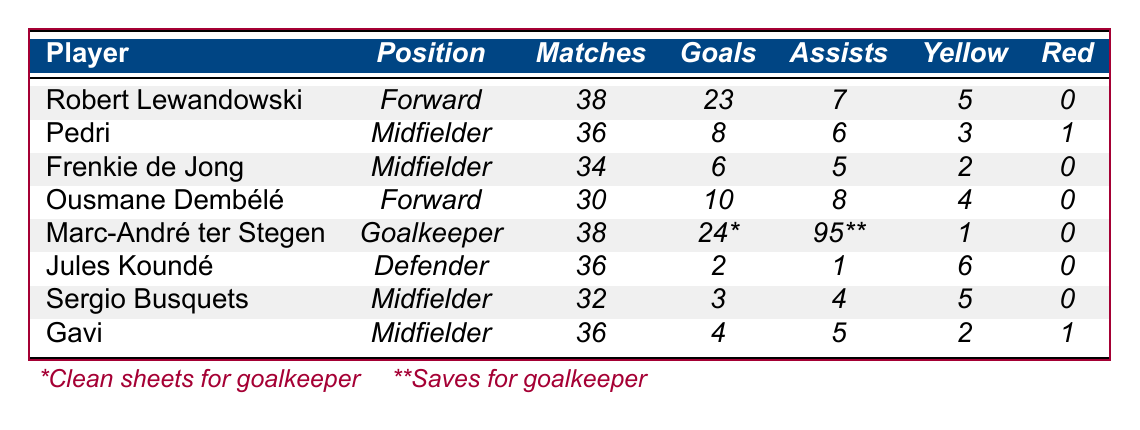What is the total number of goals scored by Robert Lewandowski and Ousmane Dembélé combined? To find the total number of goals scored by Robert Lewandowski, we take his goals (23) and add them to the goals scored by Ousmane Dembélé (10). Therefore, 23 + 10 = 33.
Answer: 33 How many assists did Pedri provide during the season? From the table, Pedri has 6 assists listed. This is directly retrieved from the data.
Answer: 6 Which player received the most yellow cards and how many did they receive? By checking the yellow cards column, we see that Jules Koundé has the highest number with 6 yellow cards compared to other players.
Answer: Jules Koundé, 6 What is the average number of goals scored by midfielders in the season? There are three midfielders (Pedri, Frenkie de Jong, Sergio Busquets, and Gavi) with respective goals of 8, 6, 3, and 4. The sum is 8 + 6 + 3 + 4 = 21. There are 4 midfielders, so the average is 21/4 = 5.25.
Answer: 5.25 Did any player have more red cards than yellow cards? Looking at the table, most players have 0 red cards. Only Pedri and Gavi have red cards, and both have fewer yellow cards than red cards (1 red for each). So the answer is no.
Answer: No How many clean sheets did Marc-André ter Stegen achieve compared to the goals scored by Frenkie de Jong? Marc-André ter Stegen had 24 clean sheets, and Frenkie de Jong scored 6 goals. There is no direct relationship, but simply comparing them finds 24 clean sheets versus 6 goals.
Answer: 24 clean sheets vs. 6 goals What is the total number of matches played by Barcelona FC players listed in the table? By summing up matches played: 38 (Lewandowski) + 36 (Pedri) + 34 (Frenkie de Jong) + 30 (Dembélé) + 38 (ter Stegen) + 36 (Koundé) + 32 (Busquets) + 36 (Gavi) =  38 + 36 + 34 + 30 + 38 + 36 + 32 + 36 =  248.
Answer: 248 Which forward had the highest number of assists? Ousmane Dembélé, with 8 assists, has the highest among forwards. Robert Lewandowski has 7 assists. The answer is determined by comparing their assist statistics.
Answer: Ousmane Dembélé How many total matches did Sergio Busquets and Frenkie de Jong play together? Sergio Busquets played 32 matches and Frenkie de Jong played 34 matches. Adding these two gives 32 + 34 = 66 matches in total.
Answer: 66 Was there any player who played more than 36 matches and did not receive any red cards? Yes, both Marc-André ter Stegen (38 matches) and Robert Lewandowski (38 matches) did not receive red cards. This can be confirmed by checking the matches column along with the red cards column.
Answer: Yes What percentage of matches played by players resulted in goals from Robert Lewandowski? Robert Lewandowski played 38 matches and scored 23 goals. To find the percentage, divide 23 by 38 and multiply by 100 to get (23/38)*100 = 60.53%.
Answer: 60.53% 